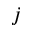Convert formula to latex. <formula><loc_0><loc_0><loc_500><loc_500>j</formula> 